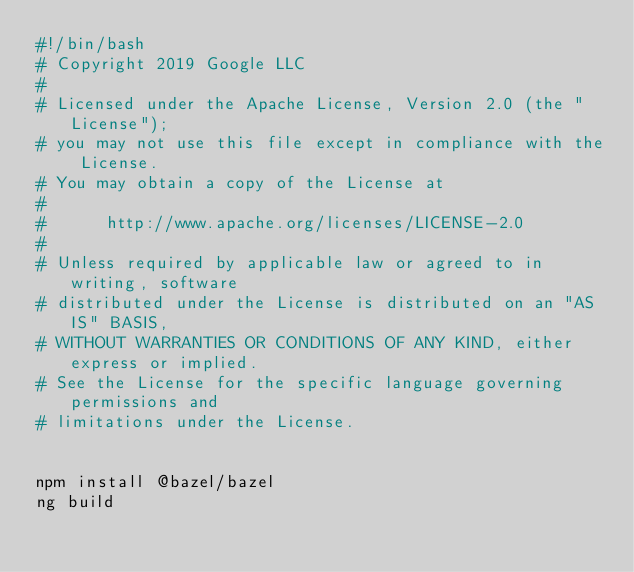<code> <loc_0><loc_0><loc_500><loc_500><_Bash_>#!/bin/bash
# Copyright 2019 Google LLC
#
# Licensed under the Apache License, Version 2.0 (the "License");
# you may not use this file except in compliance with the License.
# You may obtain a copy of the License at
#
#      http://www.apache.org/licenses/LICENSE-2.0
#
# Unless required by applicable law or agreed to in writing, software
# distributed under the License is distributed on an "AS IS" BASIS,
# WITHOUT WARRANTIES OR CONDITIONS OF ANY KIND, either express or implied.
# See the License for the specific language governing permissions and
# limitations under the License.


npm install @bazel/bazel
ng build</code> 